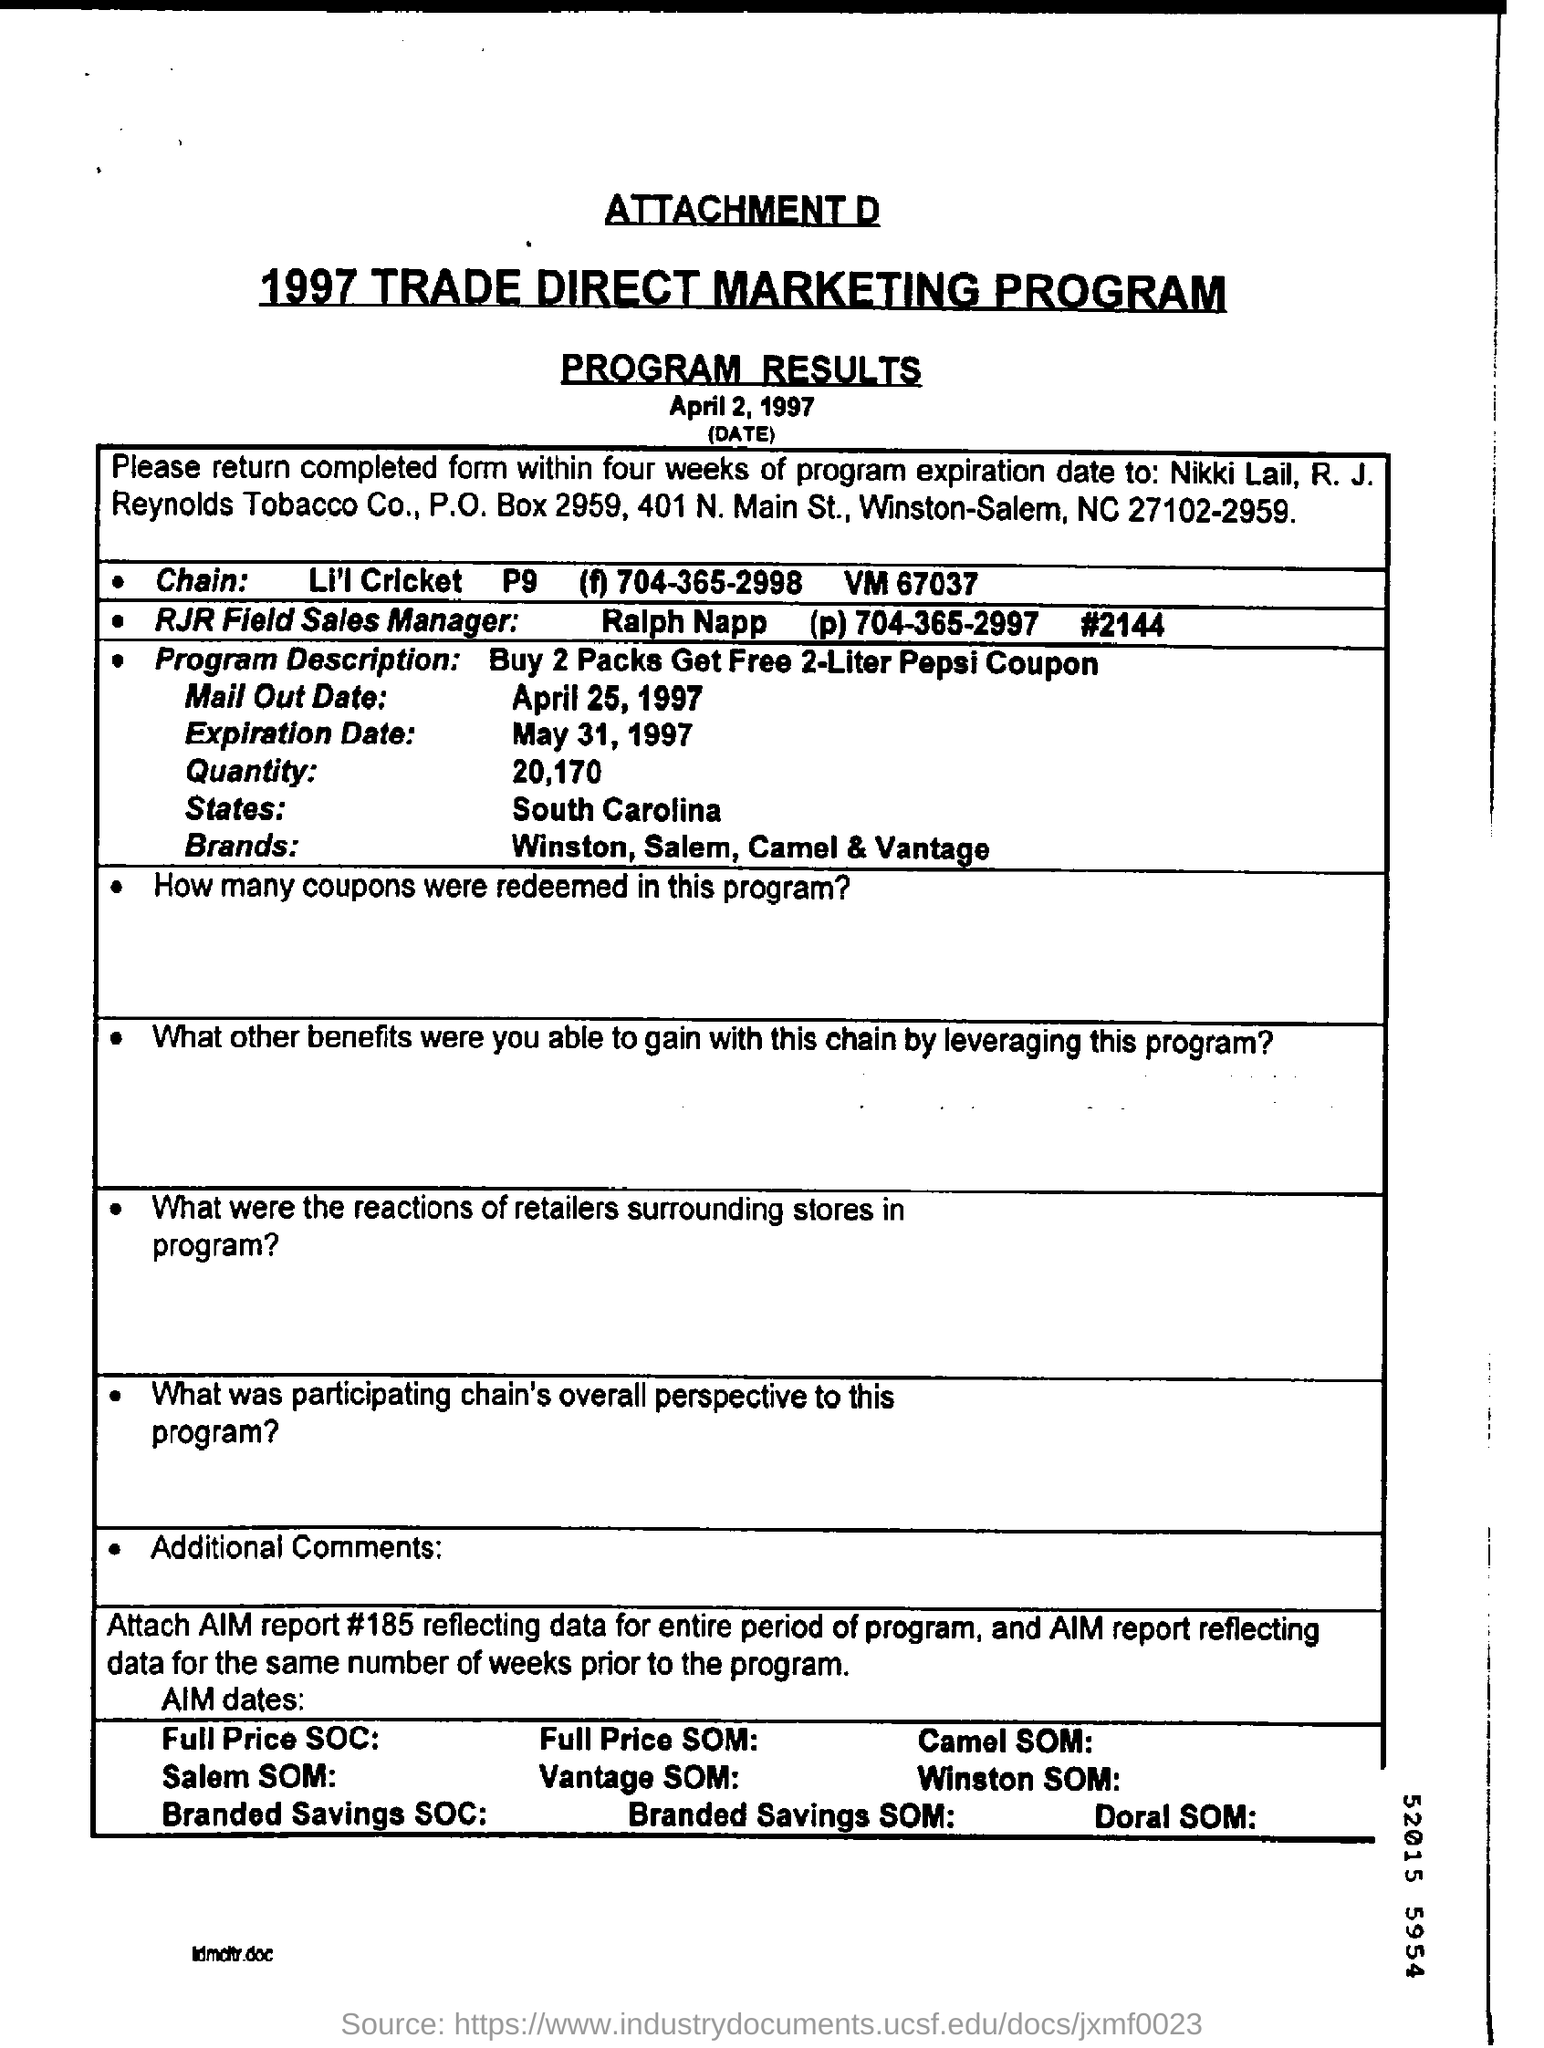Specify some key components in this picture. The program was applicable in the state of South Carolina. 